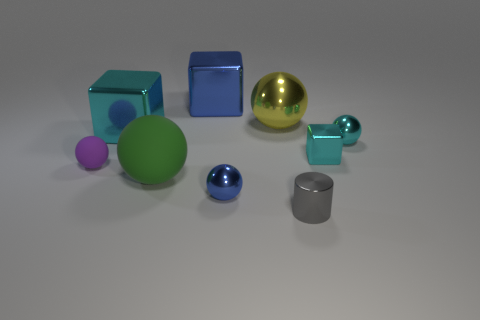Subtract all small blue spheres. How many spheres are left? 4 Subtract all green balls. How many balls are left? 4 Subtract 3 balls. How many balls are left? 2 Subtract all brown balls. Subtract all red blocks. How many balls are left? 5 Add 1 yellow shiny cubes. How many objects exist? 10 Subtract all cylinders. How many objects are left? 8 Subtract all yellow cylinders. Subtract all tiny cyan objects. How many objects are left? 7 Add 7 big yellow things. How many big yellow things are left? 8 Add 7 brown things. How many brown things exist? 7 Subtract 0 blue cylinders. How many objects are left? 9 